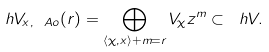Convert formula to latex. <formula><loc_0><loc_0><loc_500><loc_500>\ h V _ { x , \ A o } ( r ) = \bigoplus _ { \langle \chi , x \rangle + m = r } V _ { \chi } z ^ { m } \subset \ h V .</formula> 